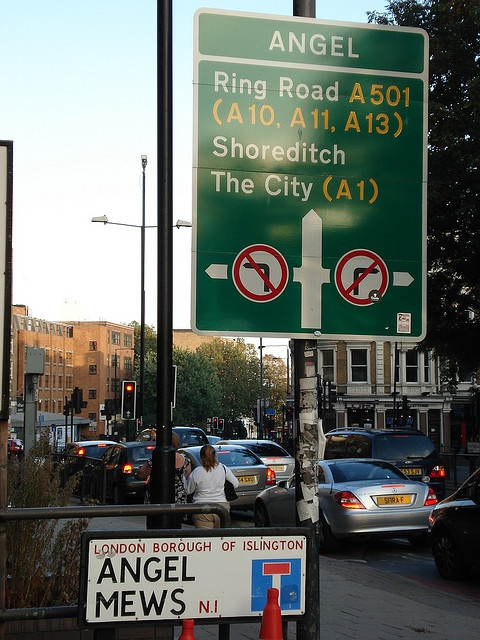Describe the objects in this image and their specific colors. I can see car in lightblue, black, gray, blue, and darkgray tones, car in lightblue, black, gray, and maroon tones, car in lightblue, black, navy, gray, and blue tones, car in lightblue, black, blue, gray, and navy tones, and people in lightblue, darkgray, black, gray, and maroon tones in this image. 